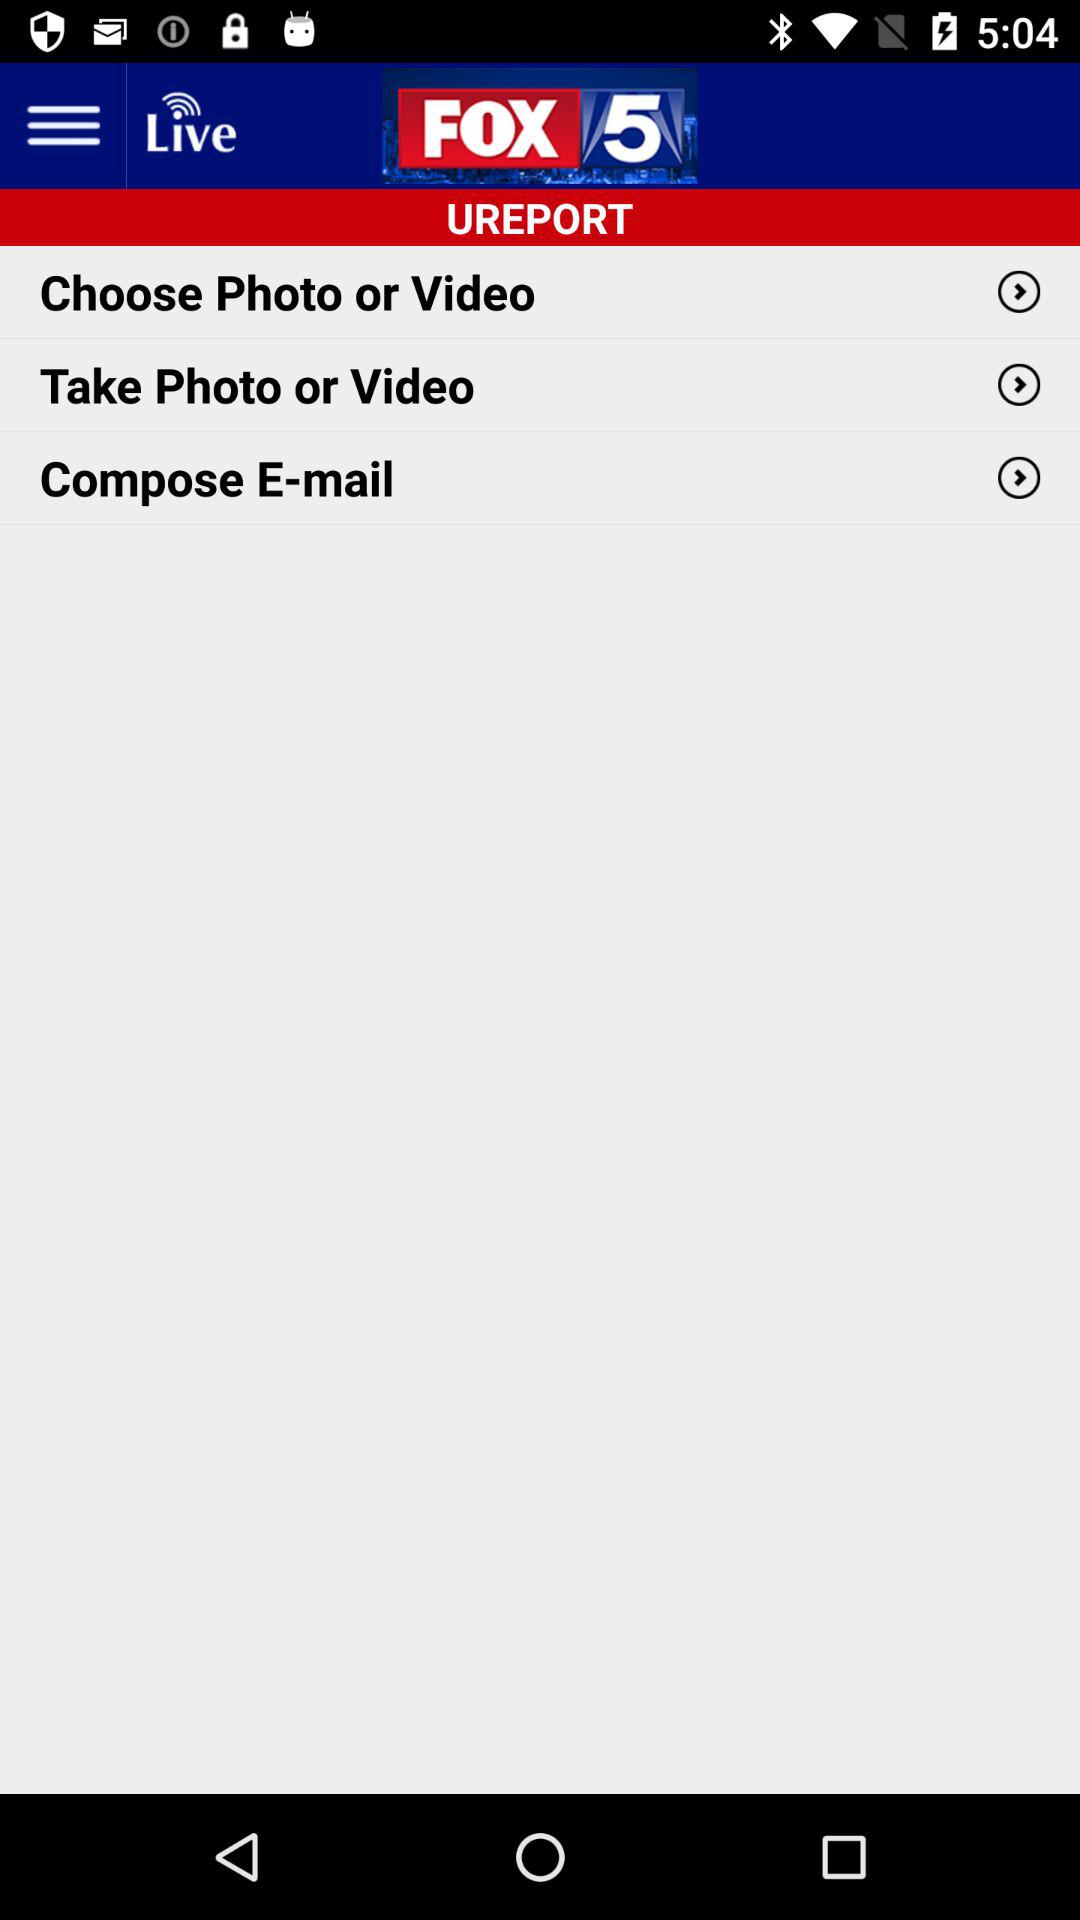What is the name of the application? The name of the application is "FOX 5". 